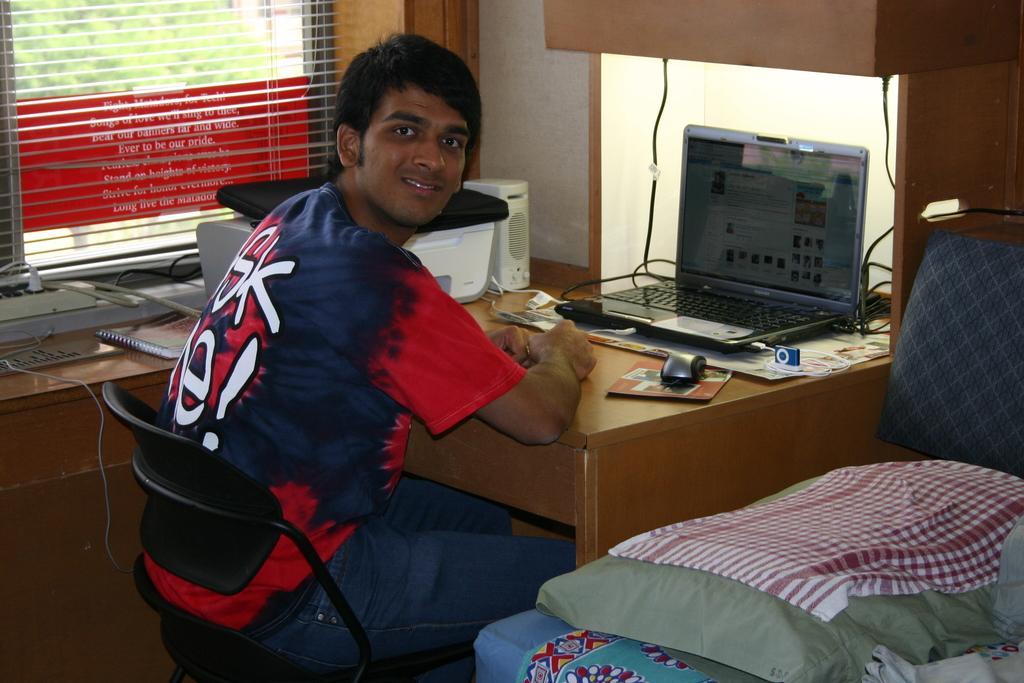Can you describe this image briefly? This picture is mainly highlighted with a man sitting on the chair in front of a laptop. This is a table. Near to the man there is a window and a printer machine. This is an adapter socket. At the right side of the picture we can see a pillow with a bed. 